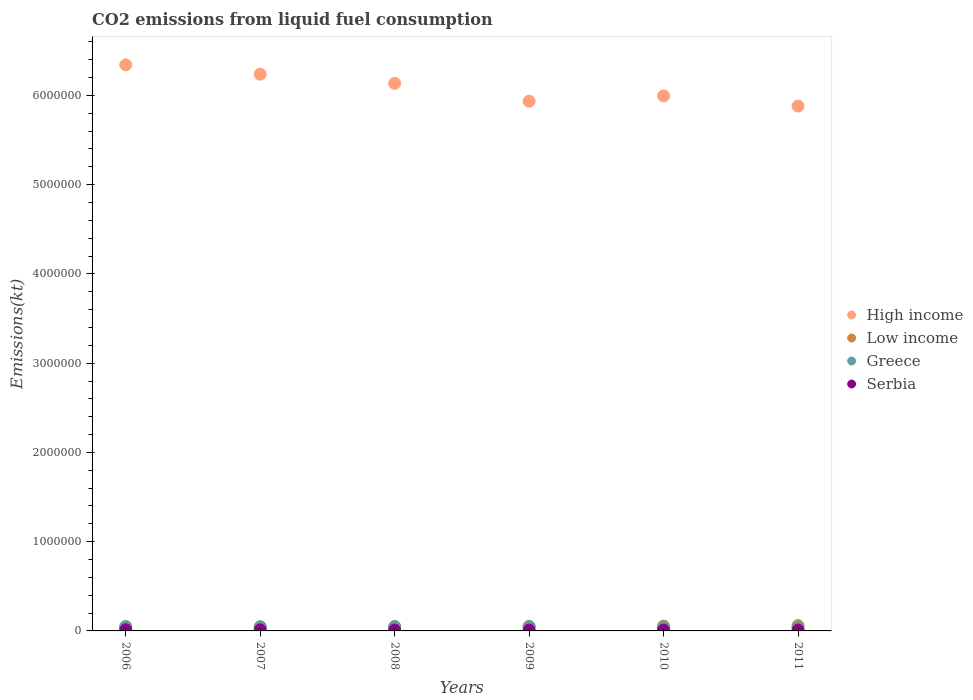Is the number of dotlines equal to the number of legend labels?
Provide a short and direct response. Yes. What is the amount of CO2 emitted in Low income in 2010?
Your answer should be compact. 5.45e+04. Across all years, what is the maximum amount of CO2 emitted in Greece?
Your answer should be very brief. 4.99e+04. Across all years, what is the minimum amount of CO2 emitted in High income?
Offer a very short reply. 5.88e+06. What is the total amount of CO2 emitted in High income in the graph?
Provide a succinct answer. 3.65e+07. What is the difference between the amount of CO2 emitted in High income in 2008 and that in 2011?
Provide a succinct answer. 2.54e+05. What is the difference between the amount of CO2 emitted in Greece in 2007 and the amount of CO2 emitted in Serbia in 2010?
Offer a terse response. 3.77e+04. What is the average amount of CO2 emitted in Serbia per year?
Provide a short and direct response. 1.08e+04. In the year 2008, what is the difference between the amount of CO2 emitted in Serbia and amount of CO2 emitted in Low income?
Keep it short and to the point. -3.77e+04. What is the ratio of the amount of CO2 emitted in Low income in 2007 to that in 2010?
Your answer should be very brief. 0.81. What is the difference between the highest and the second highest amount of CO2 emitted in Serbia?
Provide a short and direct response. 1386.13. What is the difference between the highest and the lowest amount of CO2 emitted in High income?
Give a very brief answer. 4.62e+05. In how many years, is the amount of CO2 emitted in Low income greater than the average amount of CO2 emitted in Low income taken over all years?
Ensure brevity in your answer.  3. Is it the case that in every year, the sum of the amount of CO2 emitted in Greece and amount of CO2 emitted in High income  is greater than the amount of CO2 emitted in Low income?
Your response must be concise. Yes. How many dotlines are there?
Provide a short and direct response. 4. How many years are there in the graph?
Offer a terse response. 6. Where does the legend appear in the graph?
Your response must be concise. Center right. How are the legend labels stacked?
Your answer should be very brief. Vertical. What is the title of the graph?
Offer a terse response. CO2 emissions from liquid fuel consumption. What is the label or title of the X-axis?
Make the answer very short. Years. What is the label or title of the Y-axis?
Your response must be concise. Emissions(kt). What is the Emissions(kt) in High income in 2006?
Your answer should be very brief. 6.34e+06. What is the Emissions(kt) of Low income in 2006?
Give a very brief answer. 4.06e+04. What is the Emissions(kt) of Greece in 2006?
Provide a succinct answer. 4.99e+04. What is the Emissions(kt) in Serbia in 2006?
Offer a very short reply. 1.35e+04. What is the Emissions(kt) of High income in 2007?
Your answer should be compact. 6.24e+06. What is the Emissions(kt) of Low income in 2007?
Provide a short and direct response. 4.41e+04. What is the Emissions(kt) in Greece in 2007?
Offer a terse response. 4.73e+04. What is the Emissions(kt) in Serbia in 2007?
Your answer should be very brief. 1.21e+04. What is the Emissions(kt) of High income in 2008?
Provide a short and direct response. 6.14e+06. What is the Emissions(kt) of Low income in 2008?
Your answer should be very brief. 4.80e+04. What is the Emissions(kt) of Greece in 2008?
Your answer should be compact. 4.88e+04. What is the Emissions(kt) in Serbia in 2008?
Keep it short and to the point. 1.03e+04. What is the Emissions(kt) in High income in 2009?
Keep it short and to the point. 5.94e+06. What is the Emissions(kt) of Low income in 2009?
Offer a very short reply. 5.10e+04. What is the Emissions(kt) of Greece in 2009?
Ensure brevity in your answer.  4.68e+04. What is the Emissions(kt) of Serbia in 2009?
Provide a succinct answer. 1.02e+04. What is the Emissions(kt) of High income in 2010?
Ensure brevity in your answer.  6.00e+06. What is the Emissions(kt) of Low income in 2010?
Give a very brief answer. 5.45e+04. What is the Emissions(kt) in Greece in 2010?
Your answer should be very brief. 4.08e+04. What is the Emissions(kt) in Serbia in 2010?
Offer a terse response. 9592.87. What is the Emissions(kt) of High income in 2011?
Make the answer very short. 5.88e+06. What is the Emissions(kt) in Low income in 2011?
Offer a terse response. 5.92e+04. What is the Emissions(kt) in Greece in 2011?
Provide a succinct answer. 3.68e+04. What is the Emissions(kt) in Serbia in 2011?
Give a very brief answer. 9303.18. Across all years, what is the maximum Emissions(kt) of High income?
Keep it short and to the point. 6.34e+06. Across all years, what is the maximum Emissions(kt) in Low income?
Offer a very short reply. 5.92e+04. Across all years, what is the maximum Emissions(kt) of Greece?
Your response must be concise. 4.99e+04. Across all years, what is the maximum Emissions(kt) in Serbia?
Keep it short and to the point. 1.35e+04. Across all years, what is the minimum Emissions(kt) of High income?
Provide a short and direct response. 5.88e+06. Across all years, what is the minimum Emissions(kt) of Low income?
Provide a short and direct response. 4.06e+04. Across all years, what is the minimum Emissions(kt) of Greece?
Your answer should be compact. 3.68e+04. Across all years, what is the minimum Emissions(kt) of Serbia?
Offer a terse response. 9303.18. What is the total Emissions(kt) of High income in the graph?
Give a very brief answer. 3.65e+07. What is the total Emissions(kt) in Low income in the graph?
Offer a very short reply. 2.97e+05. What is the total Emissions(kt) in Greece in the graph?
Make the answer very short. 2.70e+05. What is the total Emissions(kt) in Serbia in the graph?
Offer a terse response. 6.49e+04. What is the difference between the Emissions(kt) in High income in 2006 and that in 2007?
Your answer should be compact. 1.05e+05. What is the difference between the Emissions(kt) in Low income in 2006 and that in 2007?
Offer a very short reply. -3479.98. What is the difference between the Emissions(kt) of Greece in 2006 and that in 2007?
Your answer should be very brief. 2544.9. What is the difference between the Emissions(kt) of Serbia in 2006 and that in 2007?
Make the answer very short. 1386.13. What is the difference between the Emissions(kt) in High income in 2006 and that in 2008?
Offer a terse response. 2.08e+05. What is the difference between the Emissions(kt) of Low income in 2006 and that in 2008?
Your response must be concise. -7411.01. What is the difference between the Emissions(kt) of Greece in 2006 and that in 2008?
Give a very brief answer. 1129.44. What is the difference between the Emissions(kt) of Serbia in 2006 and that in 2008?
Provide a short and direct response. 3171.95. What is the difference between the Emissions(kt) of High income in 2006 and that in 2009?
Your response must be concise. 4.08e+05. What is the difference between the Emissions(kt) of Low income in 2006 and that in 2009?
Provide a short and direct response. -1.05e+04. What is the difference between the Emissions(kt) in Greece in 2006 and that in 2009?
Keep it short and to the point. 3061.95. What is the difference between the Emissions(kt) of Serbia in 2006 and that in 2009?
Offer a very short reply. 3296.63. What is the difference between the Emissions(kt) in High income in 2006 and that in 2010?
Give a very brief answer. 3.47e+05. What is the difference between the Emissions(kt) of Low income in 2006 and that in 2010?
Your response must be concise. -1.40e+04. What is the difference between the Emissions(kt) of Greece in 2006 and that in 2010?
Give a very brief answer. 9072.16. What is the difference between the Emissions(kt) of Serbia in 2006 and that in 2010?
Make the answer very short. 3865.02. What is the difference between the Emissions(kt) of High income in 2006 and that in 2011?
Provide a succinct answer. 4.62e+05. What is the difference between the Emissions(kt) of Low income in 2006 and that in 2011?
Your answer should be compact. -1.87e+04. What is the difference between the Emissions(kt) of Greece in 2006 and that in 2011?
Your answer should be very brief. 1.30e+04. What is the difference between the Emissions(kt) in Serbia in 2006 and that in 2011?
Give a very brief answer. 4154.71. What is the difference between the Emissions(kt) of High income in 2007 and that in 2008?
Offer a terse response. 1.03e+05. What is the difference between the Emissions(kt) in Low income in 2007 and that in 2008?
Your response must be concise. -3931.02. What is the difference between the Emissions(kt) of Greece in 2007 and that in 2008?
Your answer should be very brief. -1415.46. What is the difference between the Emissions(kt) of Serbia in 2007 and that in 2008?
Provide a succinct answer. 1785.83. What is the difference between the Emissions(kt) in High income in 2007 and that in 2009?
Ensure brevity in your answer.  3.03e+05. What is the difference between the Emissions(kt) in Low income in 2007 and that in 2009?
Your answer should be very brief. -6974.63. What is the difference between the Emissions(kt) of Greece in 2007 and that in 2009?
Offer a very short reply. 517.05. What is the difference between the Emissions(kt) in Serbia in 2007 and that in 2009?
Your answer should be very brief. 1910.51. What is the difference between the Emissions(kt) of High income in 2007 and that in 2010?
Make the answer very short. 2.42e+05. What is the difference between the Emissions(kt) in Low income in 2007 and that in 2010?
Offer a very short reply. -1.05e+04. What is the difference between the Emissions(kt) in Greece in 2007 and that in 2010?
Provide a succinct answer. 6527.26. What is the difference between the Emissions(kt) in Serbia in 2007 and that in 2010?
Make the answer very short. 2478.89. What is the difference between the Emissions(kt) in High income in 2007 and that in 2011?
Make the answer very short. 3.57e+05. What is the difference between the Emissions(kt) in Low income in 2007 and that in 2011?
Offer a terse response. -1.52e+04. What is the difference between the Emissions(kt) of Greece in 2007 and that in 2011?
Ensure brevity in your answer.  1.05e+04. What is the difference between the Emissions(kt) of Serbia in 2007 and that in 2011?
Your response must be concise. 2768.59. What is the difference between the Emissions(kt) in High income in 2008 and that in 2009?
Make the answer very short. 2.00e+05. What is the difference between the Emissions(kt) in Low income in 2008 and that in 2009?
Provide a succinct answer. -3043.61. What is the difference between the Emissions(kt) in Greece in 2008 and that in 2009?
Provide a succinct answer. 1932.51. What is the difference between the Emissions(kt) of Serbia in 2008 and that in 2009?
Your response must be concise. 124.68. What is the difference between the Emissions(kt) in High income in 2008 and that in 2010?
Your response must be concise. 1.40e+05. What is the difference between the Emissions(kt) of Low income in 2008 and that in 2010?
Provide a short and direct response. -6549.26. What is the difference between the Emissions(kt) in Greece in 2008 and that in 2010?
Your answer should be very brief. 7942.72. What is the difference between the Emissions(kt) of Serbia in 2008 and that in 2010?
Your answer should be very brief. 693.06. What is the difference between the Emissions(kt) of High income in 2008 and that in 2011?
Provide a short and direct response. 2.54e+05. What is the difference between the Emissions(kt) of Low income in 2008 and that in 2011?
Provide a succinct answer. -1.12e+04. What is the difference between the Emissions(kt) in Greece in 2008 and that in 2011?
Your answer should be very brief. 1.19e+04. What is the difference between the Emissions(kt) of Serbia in 2008 and that in 2011?
Your answer should be very brief. 982.76. What is the difference between the Emissions(kt) in High income in 2009 and that in 2010?
Your answer should be very brief. -6.02e+04. What is the difference between the Emissions(kt) of Low income in 2009 and that in 2010?
Provide a succinct answer. -3505.65. What is the difference between the Emissions(kt) in Greece in 2009 and that in 2010?
Keep it short and to the point. 6010.21. What is the difference between the Emissions(kt) in Serbia in 2009 and that in 2010?
Provide a succinct answer. 568.38. What is the difference between the Emissions(kt) of High income in 2009 and that in 2011?
Offer a very short reply. 5.44e+04. What is the difference between the Emissions(kt) in Low income in 2009 and that in 2011?
Keep it short and to the point. -8203.08. What is the difference between the Emissions(kt) of Greece in 2009 and that in 2011?
Make the answer very short. 9985.24. What is the difference between the Emissions(kt) in Serbia in 2009 and that in 2011?
Ensure brevity in your answer.  858.08. What is the difference between the Emissions(kt) of High income in 2010 and that in 2011?
Your answer should be very brief. 1.15e+05. What is the difference between the Emissions(kt) of Low income in 2010 and that in 2011?
Keep it short and to the point. -4697.43. What is the difference between the Emissions(kt) in Greece in 2010 and that in 2011?
Provide a short and direct response. 3975.03. What is the difference between the Emissions(kt) in Serbia in 2010 and that in 2011?
Make the answer very short. 289.69. What is the difference between the Emissions(kt) of High income in 2006 and the Emissions(kt) of Low income in 2007?
Offer a very short reply. 6.30e+06. What is the difference between the Emissions(kt) of High income in 2006 and the Emissions(kt) of Greece in 2007?
Ensure brevity in your answer.  6.30e+06. What is the difference between the Emissions(kt) in High income in 2006 and the Emissions(kt) in Serbia in 2007?
Offer a terse response. 6.33e+06. What is the difference between the Emissions(kt) of Low income in 2006 and the Emissions(kt) of Greece in 2007?
Your answer should be very brief. -6754.61. What is the difference between the Emissions(kt) in Low income in 2006 and the Emissions(kt) in Serbia in 2007?
Make the answer very short. 2.85e+04. What is the difference between the Emissions(kt) in Greece in 2006 and the Emissions(kt) in Serbia in 2007?
Offer a very short reply. 3.78e+04. What is the difference between the Emissions(kt) in High income in 2006 and the Emissions(kt) in Low income in 2008?
Provide a short and direct response. 6.30e+06. What is the difference between the Emissions(kt) of High income in 2006 and the Emissions(kt) of Greece in 2008?
Provide a succinct answer. 6.29e+06. What is the difference between the Emissions(kt) of High income in 2006 and the Emissions(kt) of Serbia in 2008?
Make the answer very short. 6.33e+06. What is the difference between the Emissions(kt) of Low income in 2006 and the Emissions(kt) of Greece in 2008?
Your response must be concise. -8170.08. What is the difference between the Emissions(kt) of Low income in 2006 and the Emissions(kt) of Serbia in 2008?
Your answer should be compact. 3.03e+04. What is the difference between the Emissions(kt) in Greece in 2006 and the Emissions(kt) in Serbia in 2008?
Offer a terse response. 3.96e+04. What is the difference between the Emissions(kt) of High income in 2006 and the Emissions(kt) of Low income in 2009?
Keep it short and to the point. 6.29e+06. What is the difference between the Emissions(kt) in High income in 2006 and the Emissions(kt) in Greece in 2009?
Provide a succinct answer. 6.30e+06. What is the difference between the Emissions(kt) of High income in 2006 and the Emissions(kt) of Serbia in 2009?
Provide a succinct answer. 6.33e+06. What is the difference between the Emissions(kt) in Low income in 2006 and the Emissions(kt) in Greece in 2009?
Ensure brevity in your answer.  -6237.57. What is the difference between the Emissions(kt) in Low income in 2006 and the Emissions(kt) in Serbia in 2009?
Provide a short and direct response. 3.04e+04. What is the difference between the Emissions(kt) of Greece in 2006 and the Emissions(kt) of Serbia in 2009?
Give a very brief answer. 3.97e+04. What is the difference between the Emissions(kt) in High income in 2006 and the Emissions(kt) in Low income in 2010?
Your answer should be compact. 6.29e+06. What is the difference between the Emissions(kt) in High income in 2006 and the Emissions(kt) in Greece in 2010?
Give a very brief answer. 6.30e+06. What is the difference between the Emissions(kt) of High income in 2006 and the Emissions(kt) of Serbia in 2010?
Make the answer very short. 6.33e+06. What is the difference between the Emissions(kt) of Low income in 2006 and the Emissions(kt) of Greece in 2010?
Your answer should be very brief. -227.35. What is the difference between the Emissions(kt) in Low income in 2006 and the Emissions(kt) in Serbia in 2010?
Ensure brevity in your answer.  3.10e+04. What is the difference between the Emissions(kt) in Greece in 2006 and the Emissions(kt) in Serbia in 2010?
Your response must be concise. 4.03e+04. What is the difference between the Emissions(kt) of High income in 2006 and the Emissions(kt) of Low income in 2011?
Your response must be concise. 6.28e+06. What is the difference between the Emissions(kt) of High income in 2006 and the Emissions(kt) of Greece in 2011?
Ensure brevity in your answer.  6.31e+06. What is the difference between the Emissions(kt) of High income in 2006 and the Emissions(kt) of Serbia in 2011?
Provide a succinct answer. 6.33e+06. What is the difference between the Emissions(kt) of Low income in 2006 and the Emissions(kt) of Greece in 2011?
Your response must be concise. 3747.67. What is the difference between the Emissions(kt) in Low income in 2006 and the Emissions(kt) in Serbia in 2011?
Your response must be concise. 3.13e+04. What is the difference between the Emissions(kt) in Greece in 2006 and the Emissions(kt) in Serbia in 2011?
Ensure brevity in your answer.  4.06e+04. What is the difference between the Emissions(kt) of High income in 2007 and the Emissions(kt) of Low income in 2008?
Give a very brief answer. 6.19e+06. What is the difference between the Emissions(kt) of High income in 2007 and the Emissions(kt) of Greece in 2008?
Your answer should be compact. 6.19e+06. What is the difference between the Emissions(kt) in High income in 2007 and the Emissions(kt) in Serbia in 2008?
Provide a short and direct response. 6.23e+06. What is the difference between the Emissions(kt) in Low income in 2007 and the Emissions(kt) in Greece in 2008?
Ensure brevity in your answer.  -4690.09. What is the difference between the Emissions(kt) in Low income in 2007 and the Emissions(kt) in Serbia in 2008?
Offer a terse response. 3.38e+04. What is the difference between the Emissions(kt) in Greece in 2007 and the Emissions(kt) in Serbia in 2008?
Offer a very short reply. 3.71e+04. What is the difference between the Emissions(kt) of High income in 2007 and the Emissions(kt) of Low income in 2009?
Provide a short and direct response. 6.19e+06. What is the difference between the Emissions(kt) of High income in 2007 and the Emissions(kt) of Greece in 2009?
Your answer should be very brief. 6.19e+06. What is the difference between the Emissions(kt) in High income in 2007 and the Emissions(kt) in Serbia in 2009?
Offer a terse response. 6.23e+06. What is the difference between the Emissions(kt) of Low income in 2007 and the Emissions(kt) of Greece in 2009?
Your response must be concise. -2757.58. What is the difference between the Emissions(kt) of Low income in 2007 and the Emissions(kt) of Serbia in 2009?
Offer a very short reply. 3.39e+04. What is the difference between the Emissions(kt) of Greece in 2007 and the Emissions(kt) of Serbia in 2009?
Provide a succinct answer. 3.72e+04. What is the difference between the Emissions(kt) in High income in 2007 and the Emissions(kt) in Low income in 2010?
Provide a short and direct response. 6.18e+06. What is the difference between the Emissions(kt) in High income in 2007 and the Emissions(kt) in Greece in 2010?
Ensure brevity in your answer.  6.20e+06. What is the difference between the Emissions(kt) of High income in 2007 and the Emissions(kt) of Serbia in 2010?
Keep it short and to the point. 6.23e+06. What is the difference between the Emissions(kt) of Low income in 2007 and the Emissions(kt) of Greece in 2010?
Provide a short and direct response. 3252.63. What is the difference between the Emissions(kt) of Low income in 2007 and the Emissions(kt) of Serbia in 2010?
Ensure brevity in your answer.  3.45e+04. What is the difference between the Emissions(kt) of Greece in 2007 and the Emissions(kt) of Serbia in 2010?
Make the answer very short. 3.77e+04. What is the difference between the Emissions(kt) of High income in 2007 and the Emissions(kt) of Low income in 2011?
Provide a succinct answer. 6.18e+06. What is the difference between the Emissions(kt) in High income in 2007 and the Emissions(kt) in Greece in 2011?
Make the answer very short. 6.20e+06. What is the difference between the Emissions(kt) of High income in 2007 and the Emissions(kt) of Serbia in 2011?
Give a very brief answer. 6.23e+06. What is the difference between the Emissions(kt) in Low income in 2007 and the Emissions(kt) in Greece in 2011?
Keep it short and to the point. 7227.66. What is the difference between the Emissions(kt) in Low income in 2007 and the Emissions(kt) in Serbia in 2011?
Your response must be concise. 3.48e+04. What is the difference between the Emissions(kt) of Greece in 2007 and the Emissions(kt) of Serbia in 2011?
Keep it short and to the point. 3.80e+04. What is the difference between the Emissions(kt) in High income in 2008 and the Emissions(kt) in Low income in 2009?
Offer a very short reply. 6.08e+06. What is the difference between the Emissions(kt) of High income in 2008 and the Emissions(kt) of Greece in 2009?
Ensure brevity in your answer.  6.09e+06. What is the difference between the Emissions(kt) in High income in 2008 and the Emissions(kt) in Serbia in 2009?
Provide a succinct answer. 6.13e+06. What is the difference between the Emissions(kt) of Low income in 2008 and the Emissions(kt) of Greece in 2009?
Your answer should be very brief. 1173.44. What is the difference between the Emissions(kt) of Low income in 2008 and the Emissions(kt) of Serbia in 2009?
Ensure brevity in your answer.  3.78e+04. What is the difference between the Emissions(kt) in Greece in 2008 and the Emissions(kt) in Serbia in 2009?
Your answer should be very brief. 3.86e+04. What is the difference between the Emissions(kt) in High income in 2008 and the Emissions(kt) in Low income in 2010?
Offer a terse response. 6.08e+06. What is the difference between the Emissions(kt) of High income in 2008 and the Emissions(kt) of Greece in 2010?
Give a very brief answer. 6.09e+06. What is the difference between the Emissions(kt) of High income in 2008 and the Emissions(kt) of Serbia in 2010?
Your answer should be compact. 6.13e+06. What is the difference between the Emissions(kt) of Low income in 2008 and the Emissions(kt) of Greece in 2010?
Make the answer very short. 7183.65. What is the difference between the Emissions(kt) of Low income in 2008 and the Emissions(kt) of Serbia in 2010?
Give a very brief answer. 3.84e+04. What is the difference between the Emissions(kt) in Greece in 2008 and the Emissions(kt) in Serbia in 2010?
Provide a succinct answer. 3.92e+04. What is the difference between the Emissions(kt) in High income in 2008 and the Emissions(kt) in Low income in 2011?
Ensure brevity in your answer.  6.08e+06. What is the difference between the Emissions(kt) in High income in 2008 and the Emissions(kt) in Greece in 2011?
Ensure brevity in your answer.  6.10e+06. What is the difference between the Emissions(kt) in High income in 2008 and the Emissions(kt) in Serbia in 2011?
Offer a very short reply. 6.13e+06. What is the difference between the Emissions(kt) in Low income in 2008 and the Emissions(kt) in Greece in 2011?
Your response must be concise. 1.12e+04. What is the difference between the Emissions(kt) of Low income in 2008 and the Emissions(kt) of Serbia in 2011?
Keep it short and to the point. 3.87e+04. What is the difference between the Emissions(kt) in Greece in 2008 and the Emissions(kt) in Serbia in 2011?
Keep it short and to the point. 3.95e+04. What is the difference between the Emissions(kt) in High income in 2009 and the Emissions(kt) in Low income in 2010?
Offer a very short reply. 5.88e+06. What is the difference between the Emissions(kt) of High income in 2009 and the Emissions(kt) of Greece in 2010?
Keep it short and to the point. 5.89e+06. What is the difference between the Emissions(kt) of High income in 2009 and the Emissions(kt) of Serbia in 2010?
Ensure brevity in your answer.  5.93e+06. What is the difference between the Emissions(kt) of Low income in 2009 and the Emissions(kt) of Greece in 2010?
Your answer should be compact. 1.02e+04. What is the difference between the Emissions(kt) in Low income in 2009 and the Emissions(kt) in Serbia in 2010?
Offer a terse response. 4.14e+04. What is the difference between the Emissions(kt) in Greece in 2009 and the Emissions(kt) in Serbia in 2010?
Your answer should be very brief. 3.72e+04. What is the difference between the Emissions(kt) in High income in 2009 and the Emissions(kt) in Low income in 2011?
Give a very brief answer. 5.88e+06. What is the difference between the Emissions(kt) of High income in 2009 and the Emissions(kt) of Greece in 2011?
Provide a succinct answer. 5.90e+06. What is the difference between the Emissions(kt) in High income in 2009 and the Emissions(kt) in Serbia in 2011?
Offer a very short reply. 5.93e+06. What is the difference between the Emissions(kt) of Low income in 2009 and the Emissions(kt) of Greece in 2011?
Your answer should be compact. 1.42e+04. What is the difference between the Emissions(kt) in Low income in 2009 and the Emissions(kt) in Serbia in 2011?
Your answer should be compact. 4.17e+04. What is the difference between the Emissions(kt) in Greece in 2009 and the Emissions(kt) in Serbia in 2011?
Give a very brief answer. 3.75e+04. What is the difference between the Emissions(kt) of High income in 2010 and the Emissions(kt) of Low income in 2011?
Give a very brief answer. 5.94e+06. What is the difference between the Emissions(kt) of High income in 2010 and the Emissions(kt) of Greece in 2011?
Your response must be concise. 5.96e+06. What is the difference between the Emissions(kt) in High income in 2010 and the Emissions(kt) in Serbia in 2011?
Provide a succinct answer. 5.99e+06. What is the difference between the Emissions(kt) of Low income in 2010 and the Emissions(kt) of Greece in 2011?
Keep it short and to the point. 1.77e+04. What is the difference between the Emissions(kt) in Low income in 2010 and the Emissions(kt) in Serbia in 2011?
Offer a very short reply. 4.52e+04. What is the difference between the Emissions(kt) in Greece in 2010 and the Emissions(kt) in Serbia in 2011?
Offer a terse response. 3.15e+04. What is the average Emissions(kt) in High income per year?
Offer a very short reply. 6.09e+06. What is the average Emissions(kt) in Low income per year?
Keep it short and to the point. 4.96e+04. What is the average Emissions(kt) in Greece per year?
Make the answer very short. 4.51e+04. What is the average Emissions(kt) in Serbia per year?
Provide a succinct answer. 1.08e+04. In the year 2006, what is the difference between the Emissions(kt) in High income and Emissions(kt) in Low income?
Your answer should be compact. 6.30e+06. In the year 2006, what is the difference between the Emissions(kt) in High income and Emissions(kt) in Greece?
Keep it short and to the point. 6.29e+06. In the year 2006, what is the difference between the Emissions(kt) of High income and Emissions(kt) of Serbia?
Ensure brevity in your answer.  6.33e+06. In the year 2006, what is the difference between the Emissions(kt) of Low income and Emissions(kt) of Greece?
Provide a short and direct response. -9299.51. In the year 2006, what is the difference between the Emissions(kt) in Low income and Emissions(kt) in Serbia?
Keep it short and to the point. 2.71e+04. In the year 2006, what is the difference between the Emissions(kt) in Greece and Emissions(kt) in Serbia?
Provide a succinct answer. 3.64e+04. In the year 2007, what is the difference between the Emissions(kt) of High income and Emissions(kt) of Low income?
Offer a very short reply. 6.19e+06. In the year 2007, what is the difference between the Emissions(kt) of High income and Emissions(kt) of Greece?
Provide a succinct answer. 6.19e+06. In the year 2007, what is the difference between the Emissions(kt) in High income and Emissions(kt) in Serbia?
Give a very brief answer. 6.23e+06. In the year 2007, what is the difference between the Emissions(kt) of Low income and Emissions(kt) of Greece?
Provide a short and direct response. -3274.63. In the year 2007, what is the difference between the Emissions(kt) in Low income and Emissions(kt) in Serbia?
Your response must be concise. 3.20e+04. In the year 2007, what is the difference between the Emissions(kt) of Greece and Emissions(kt) of Serbia?
Make the answer very short. 3.53e+04. In the year 2008, what is the difference between the Emissions(kt) in High income and Emissions(kt) in Low income?
Provide a short and direct response. 6.09e+06. In the year 2008, what is the difference between the Emissions(kt) in High income and Emissions(kt) in Greece?
Provide a succinct answer. 6.09e+06. In the year 2008, what is the difference between the Emissions(kt) in High income and Emissions(kt) in Serbia?
Provide a short and direct response. 6.13e+06. In the year 2008, what is the difference between the Emissions(kt) of Low income and Emissions(kt) of Greece?
Offer a terse response. -759.07. In the year 2008, what is the difference between the Emissions(kt) in Low income and Emissions(kt) in Serbia?
Your response must be concise. 3.77e+04. In the year 2008, what is the difference between the Emissions(kt) in Greece and Emissions(kt) in Serbia?
Offer a very short reply. 3.85e+04. In the year 2009, what is the difference between the Emissions(kt) in High income and Emissions(kt) in Low income?
Provide a succinct answer. 5.88e+06. In the year 2009, what is the difference between the Emissions(kt) of High income and Emissions(kt) of Greece?
Offer a very short reply. 5.89e+06. In the year 2009, what is the difference between the Emissions(kt) in High income and Emissions(kt) in Serbia?
Your response must be concise. 5.93e+06. In the year 2009, what is the difference between the Emissions(kt) in Low income and Emissions(kt) in Greece?
Your answer should be compact. 4217.05. In the year 2009, what is the difference between the Emissions(kt) of Low income and Emissions(kt) of Serbia?
Your response must be concise. 4.09e+04. In the year 2009, what is the difference between the Emissions(kt) of Greece and Emissions(kt) of Serbia?
Make the answer very short. 3.67e+04. In the year 2010, what is the difference between the Emissions(kt) of High income and Emissions(kt) of Low income?
Offer a terse response. 5.94e+06. In the year 2010, what is the difference between the Emissions(kt) of High income and Emissions(kt) of Greece?
Your response must be concise. 5.95e+06. In the year 2010, what is the difference between the Emissions(kt) in High income and Emissions(kt) in Serbia?
Offer a terse response. 5.99e+06. In the year 2010, what is the difference between the Emissions(kt) of Low income and Emissions(kt) of Greece?
Your answer should be very brief. 1.37e+04. In the year 2010, what is the difference between the Emissions(kt) in Low income and Emissions(kt) in Serbia?
Keep it short and to the point. 4.50e+04. In the year 2010, what is the difference between the Emissions(kt) of Greece and Emissions(kt) of Serbia?
Provide a short and direct response. 3.12e+04. In the year 2011, what is the difference between the Emissions(kt) in High income and Emissions(kt) in Low income?
Keep it short and to the point. 5.82e+06. In the year 2011, what is the difference between the Emissions(kt) of High income and Emissions(kt) of Greece?
Offer a very short reply. 5.84e+06. In the year 2011, what is the difference between the Emissions(kt) of High income and Emissions(kt) of Serbia?
Provide a short and direct response. 5.87e+06. In the year 2011, what is the difference between the Emissions(kt) in Low income and Emissions(kt) in Greece?
Your answer should be compact. 2.24e+04. In the year 2011, what is the difference between the Emissions(kt) in Low income and Emissions(kt) in Serbia?
Your answer should be very brief. 4.99e+04. In the year 2011, what is the difference between the Emissions(kt) of Greece and Emissions(kt) of Serbia?
Offer a terse response. 2.75e+04. What is the ratio of the Emissions(kt) in High income in 2006 to that in 2007?
Provide a short and direct response. 1.02. What is the ratio of the Emissions(kt) in Low income in 2006 to that in 2007?
Your answer should be compact. 0.92. What is the ratio of the Emissions(kt) of Greece in 2006 to that in 2007?
Give a very brief answer. 1.05. What is the ratio of the Emissions(kt) in Serbia in 2006 to that in 2007?
Your answer should be compact. 1.11. What is the ratio of the Emissions(kt) in High income in 2006 to that in 2008?
Provide a short and direct response. 1.03. What is the ratio of the Emissions(kt) of Low income in 2006 to that in 2008?
Offer a terse response. 0.85. What is the ratio of the Emissions(kt) in Greece in 2006 to that in 2008?
Your answer should be compact. 1.02. What is the ratio of the Emissions(kt) in Serbia in 2006 to that in 2008?
Your response must be concise. 1.31. What is the ratio of the Emissions(kt) in High income in 2006 to that in 2009?
Your answer should be compact. 1.07. What is the ratio of the Emissions(kt) in Low income in 2006 to that in 2009?
Provide a short and direct response. 0.8. What is the ratio of the Emissions(kt) in Greece in 2006 to that in 2009?
Give a very brief answer. 1.07. What is the ratio of the Emissions(kt) of Serbia in 2006 to that in 2009?
Keep it short and to the point. 1.32. What is the ratio of the Emissions(kt) in High income in 2006 to that in 2010?
Provide a succinct answer. 1.06. What is the ratio of the Emissions(kt) in Low income in 2006 to that in 2010?
Give a very brief answer. 0.74. What is the ratio of the Emissions(kt) in Greece in 2006 to that in 2010?
Ensure brevity in your answer.  1.22. What is the ratio of the Emissions(kt) in Serbia in 2006 to that in 2010?
Your response must be concise. 1.4. What is the ratio of the Emissions(kt) in High income in 2006 to that in 2011?
Ensure brevity in your answer.  1.08. What is the ratio of the Emissions(kt) in Low income in 2006 to that in 2011?
Keep it short and to the point. 0.69. What is the ratio of the Emissions(kt) of Greece in 2006 to that in 2011?
Provide a succinct answer. 1.35. What is the ratio of the Emissions(kt) in Serbia in 2006 to that in 2011?
Offer a terse response. 1.45. What is the ratio of the Emissions(kt) in High income in 2007 to that in 2008?
Offer a very short reply. 1.02. What is the ratio of the Emissions(kt) in Low income in 2007 to that in 2008?
Your answer should be very brief. 0.92. What is the ratio of the Emissions(kt) of Greece in 2007 to that in 2008?
Provide a succinct answer. 0.97. What is the ratio of the Emissions(kt) in Serbia in 2007 to that in 2008?
Make the answer very short. 1.17. What is the ratio of the Emissions(kt) of High income in 2007 to that in 2009?
Your answer should be compact. 1.05. What is the ratio of the Emissions(kt) in Low income in 2007 to that in 2009?
Offer a terse response. 0.86. What is the ratio of the Emissions(kt) in Greece in 2007 to that in 2009?
Keep it short and to the point. 1.01. What is the ratio of the Emissions(kt) in Serbia in 2007 to that in 2009?
Offer a very short reply. 1.19. What is the ratio of the Emissions(kt) of High income in 2007 to that in 2010?
Keep it short and to the point. 1.04. What is the ratio of the Emissions(kt) of Low income in 2007 to that in 2010?
Your answer should be compact. 0.81. What is the ratio of the Emissions(kt) in Greece in 2007 to that in 2010?
Offer a terse response. 1.16. What is the ratio of the Emissions(kt) in Serbia in 2007 to that in 2010?
Provide a succinct answer. 1.26. What is the ratio of the Emissions(kt) in High income in 2007 to that in 2011?
Provide a succinct answer. 1.06. What is the ratio of the Emissions(kt) of Low income in 2007 to that in 2011?
Your answer should be compact. 0.74. What is the ratio of the Emissions(kt) in Greece in 2007 to that in 2011?
Your answer should be very brief. 1.29. What is the ratio of the Emissions(kt) of Serbia in 2007 to that in 2011?
Provide a succinct answer. 1.3. What is the ratio of the Emissions(kt) in High income in 2008 to that in 2009?
Your answer should be compact. 1.03. What is the ratio of the Emissions(kt) in Low income in 2008 to that in 2009?
Ensure brevity in your answer.  0.94. What is the ratio of the Emissions(kt) of Greece in 2008 to that in 2009?
Keep it short and to the point. 1.04. What is the ratio of the Emissions(kt) in Serbia in 2008 to that in 2009?
Give a very brief answer. 1.01. What is the ratio of the Emissions(kt) in High income in 2008 to that in 2010?
Provide a short and direct response. 1.02. What is the ratio of the Emissions(kt) in Low income in 2008 to that in 2010?
Your answer should be very brief. 0.88. What is the ratio of the Emissions(kt) in Greece in 2008 to that in 2010?
Your answer should be very brief. 1.19. What is the ratio of the Emissions(kt) of Serbia in 2008 to that in 2010?
Your answer should be compact. 1.07. What is the ratio of the Emissions(kt) in High income in 2008 to that in 2011?
Provide a short and direct response. 1.04. What is the ratio of the Emissions(kt) in Low income in 2008 to that in 2011?
Your response must be concise. 0.81. What is the ratio of the Emissions(kt) in Greece in 2008 to that in 2011?
Keep it short and to the point. 1.32. What is the ratio of the Emissions(kt) of Serbia in 2008 to that in 2011?
Your response must be concise. 1.11. What is the ratio of the Emissions(kt) in High income in 2009 to that in 2010?
Make the answer very short. 0.99. What is the ratio of the Emissions(kt) of Low income in 2009 to that in 2010?
Make the answer very short. 0.94. What is the ratio of the Emissions(kt) of Greece in 2009 to that in 2010?
Offer a terse response. 1.15. What is the ratio of the Emissions(kt) of Serbia in 2009 to that in 2010?
Keep it short and to the point. 1.06. What is the ratio of the Emissions(kt) in High income in 2009 to that in 2011?
Give a very brief answer. 1.01. What is the ratio of the Emissions(kt) in Low income in 2009 to that in 2011?
Offer a very short reply. 0.86. What is the ratio of the Emissions(kt) of Greece in 2009 to that in 2011?
Your response must be concise. 1.27. What is the ratio of the Emissions(kt) of Serbia in 2009 to that in 2011?
Your answer should be compact. 1.09. What is the ratio of the Emissions(kt) of High income in 2010 to that in 2011?
Your answer should be very brief. 1.02. What is the ratio of the Emissions(kt) in Low income in 2010 to that in 2011?
Keep it short and to the point. 0.92. What is the ratio of the Emissions(kt) of Greece in 2010 to that in 2011?
Provide a succinct answer. 1.11. What is the ratio of the Emissions(kt) of Serbia in 2010 to that in 2011?
Keep it short and to the point. 1.03. What is the difference between the highest and the second highest Emissions(kt) in High income?
Give a very brief answer. 1.05e+05. What is the difference between the highest and the second highest Emissions(kt) of Low income?
Offer a terse response. 4697.43. What is the difference between the highest and the second highest Emissions(kt) in Greece?
Offer a terse response. 1129.44. What is the difference between the highest and the second highest Emissions(kt) in Serbia?
Provide a short and direct response. 1386.13. What is the difference between the highest and the lowest Emissions(kt) in High income?
Your answer should be very brief. 4.62e+05. What is the difference between the highest and the lowest Emissions(kt) in Low income?
Keep it short and to the point. 1.87e+04. What is the difference between the highest and the lowest Emissions(kt) in Greece?
Ensure brevity in your answer.  1.30e+04. What is the difference between the highest and the lowest Emissions(kt) of Serbia?
Make the answer very short. 4154.71. 